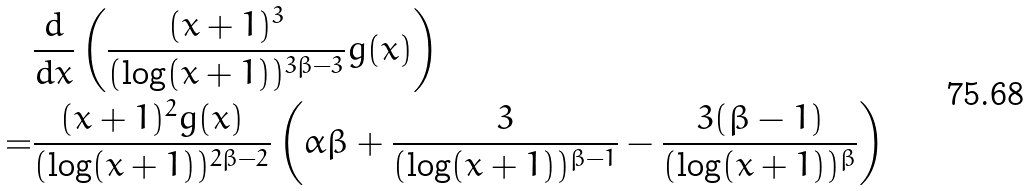<formula> <loc_0><loc_0><loc_500><loc_500>& \frac { d } { d x } \left ( \frac { ( x + 1 ) ^ { 3 } } { ( \log ( x + 1 ) ) ^ { 3 \beta - 3 } } g ( x ) \right ) \\ = & \frac { ( x + 1 ) ^ { 2 } g ( x ) } { ( \log ( x + 1 ) ) ^ { 2 \beta - 2 } } \left ( \alpha \beta + \frac { 3 } { ( \log ( x + 1 ) ) ^ { \beta - 1 } } - \frac { 3 ( \beta - 1 ) } { ( \log ( x + 1 ) ) ^ { \beta } } \right )</formula> 